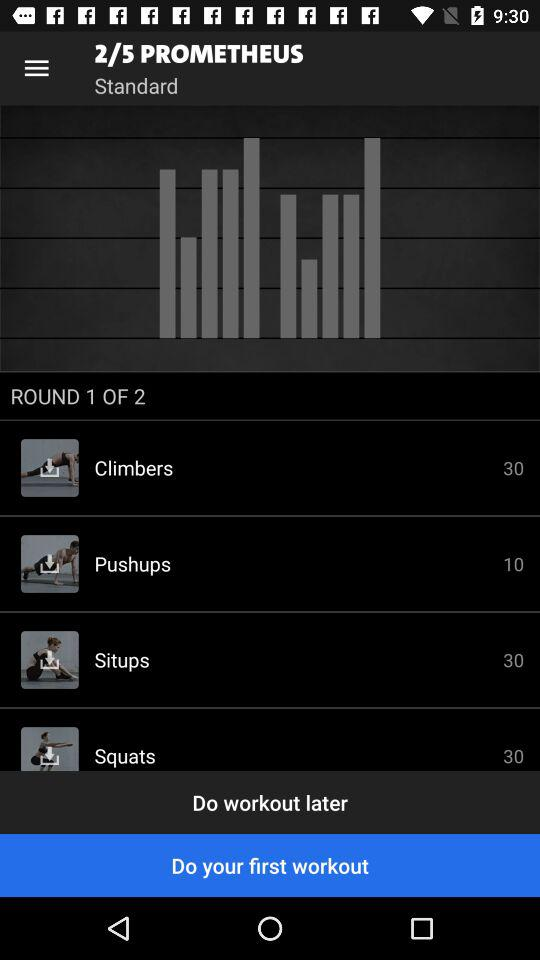Which exercise has a rep count of 10? The exercise is pushups. 